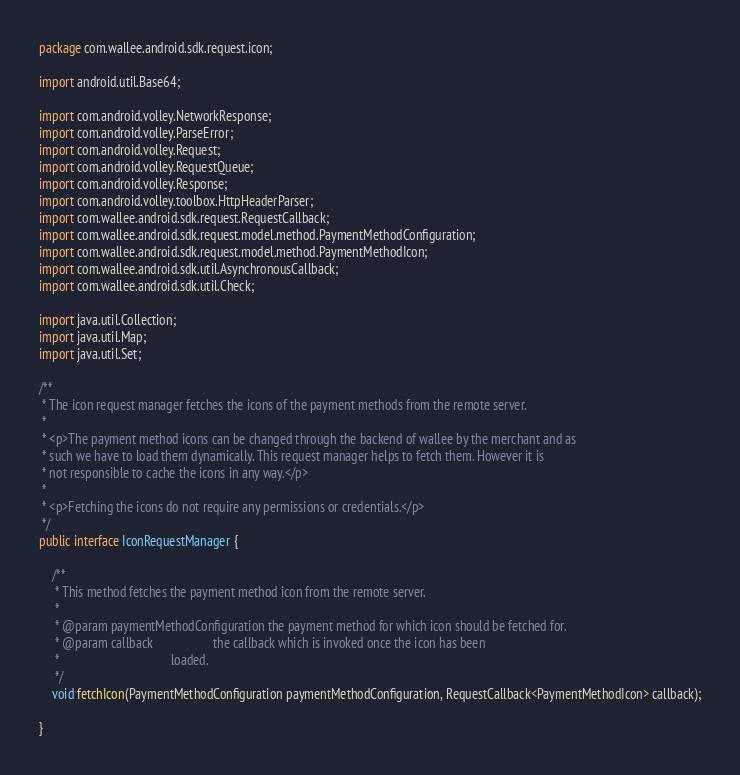Convert code to text. <code><loc_0><loc_0><loc_500><loc_500><_Java_>package com.wallee.android.sdk.request.icon;

import android.util.Base64;

import com.android.volley.NetworkResponse;
import com.android.volley.ParseError;
import com.android.volley.Request;
import com.android.volley.RequestQueue;
import com.android.volley.Response;
import com.android.volley.toolbox.HttpHeaderParser;
import com.wallee.android.sdk.request.RequestCallback;
import com.wallee.android.sdk.request.model.method.PaymentMethodConfiguration;
import com.wallee.android.sdk.request.model.method.PaymentMethodIcon;
import com.wallee.android.sdk.util.AsynchronousCallback;
import com.wallee.android.sdk.util.Check;

import java.util.Collection;
import java.util.Map;
import java.util.Set;

/**
 * The icon request manager fetches the icons of the payment methods from the remote server.
 *
 * <p>The payment method icons can be changed through the backend of wallee by the merchant and as
 * such we have to load them dynamically. This request manager helps to fetch them. However it is
 * not responsible to cache the icons in any way.</p>
 *
 * <p>Fetching the icons do not require any permissions or credentials.</p>
 */
public interface IconRequestManager {

    /**
     * This method fetches the payment method icon from the remote server.
     *
     * @param paymentMethodConfiguration the payment method for which icon should be fetched for.
     * @param callback                   the callback which is invoked once the icon has been
     *                                   loaded.
     */
    void fetchIcon(PaymentMethodConfiguration paymentMethodConfiguration, RequestCallback<PaymentMethodIcon> callback);

}
</code> 